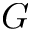<formula> <loc_0><loc_0><loc_500><loc_500>G</formula> 